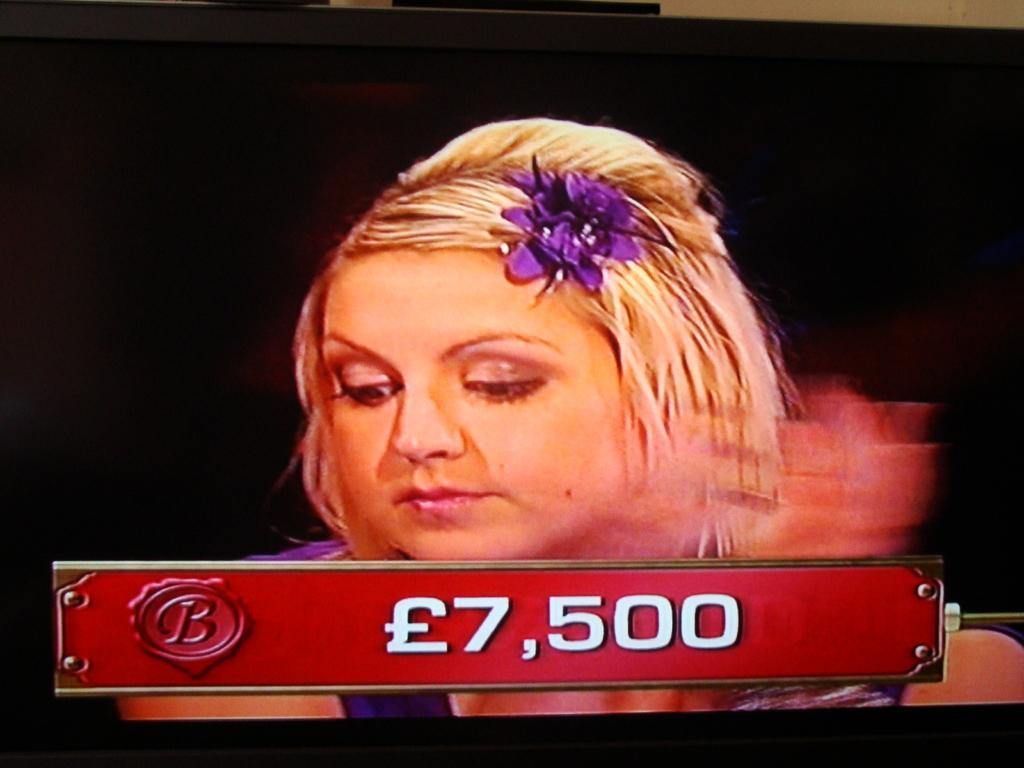How would you summarize this image in a sentence or two? In this picture, we see the woman in the purple dress is sitting. At the bottom, we see a board in red color with numbers written on it. In the background, it is black in color. Here, we see a television, which is displaying the woman on the screen. 